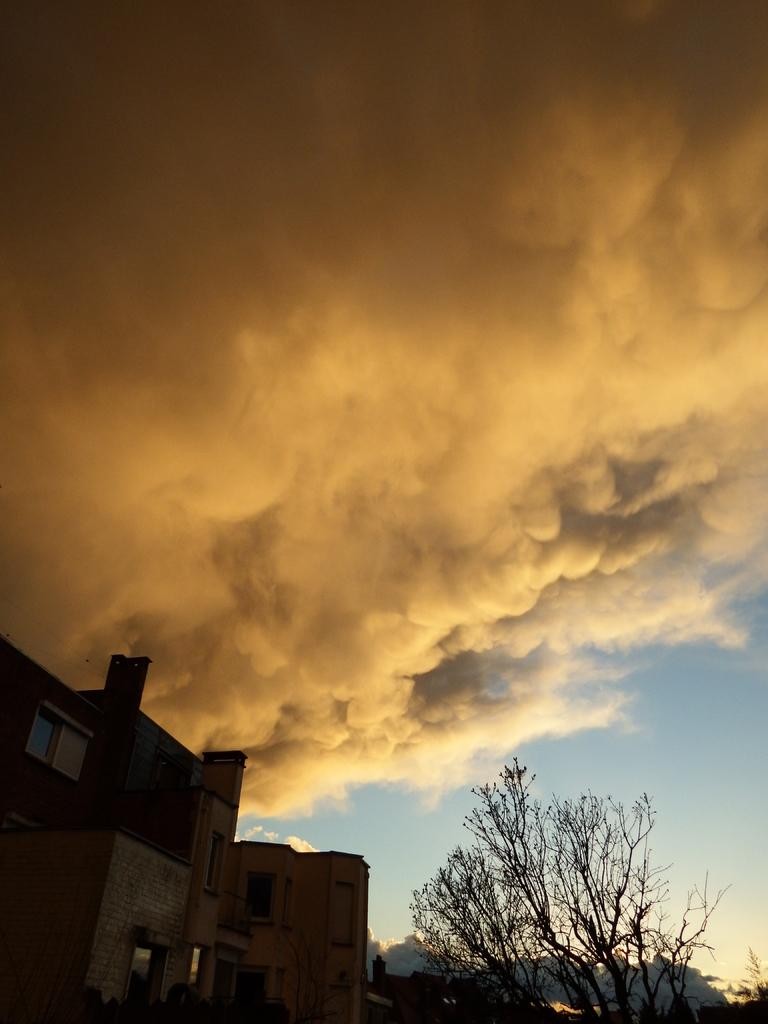What type of structures are located at the bottom of the image? There are buildings at the bottom of the image. What can be seen on the right side of the image? There is a tree on the right side of the image. What is visible at the top of the image? Smoke and the sky are visible at the top of the image. Can you tell me how many parents are involved in the fight at the top of the image? There is no fight or parents present in the image; it features buildings, a tree, smoke, and the sky. What type of slope can be seen in the image? There is no slope present in the image. 